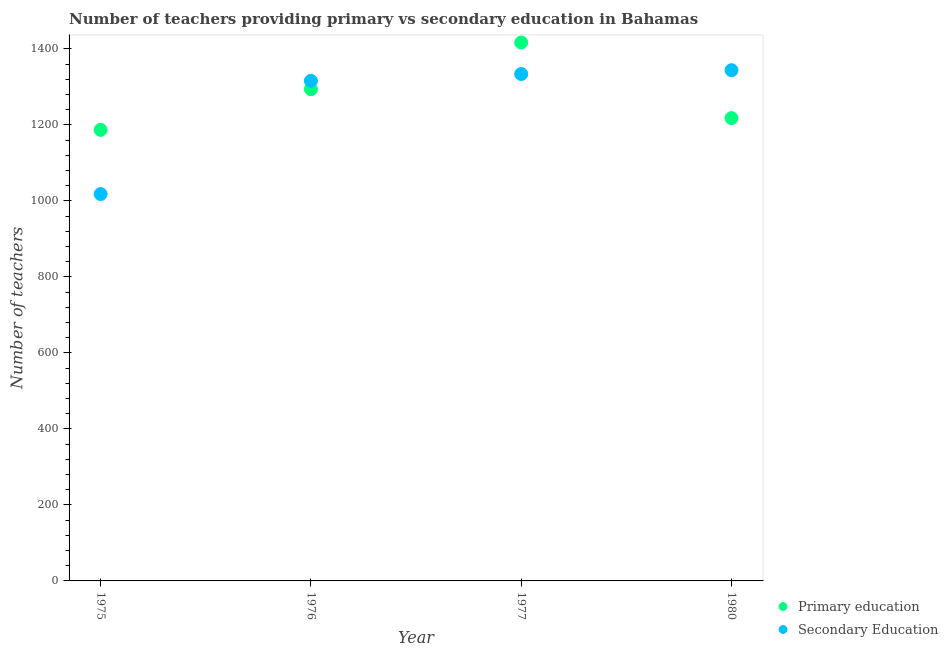Is the number of dotlines equal to the number of legend labels?
Your response must be concise. Yes. What is the number of secondary teachers in 1976?
Provide a succinct answer. 1316. Across all years, what is the maximum number of primary teachers?
Your answer should be compact. 1417. Across all years, what is the minimum number of primary teachers?
Offer a terse response. 1187. In which year was the number of secondary teachers minimum?
Your answer should be very brief. 1975. What is the total number of primary teachers in the graph?
Offer a very short reply. 5116. What is the difference between the number of primary teachers in 1976 and that in 1980?
Give a very brief answer. 76. What is the difference between the number of primary teachers in 1976 and the number of secondary teachers in 1980?
Offer a terse response. -50. What is the average number of primary teachers per year?
Ensure brevity in your answer.  1279. In the year 1975, what is the difference between the number of primary teachers and number of secondary teachers?
Offer a very short reply. 169. In how many years, is the number of primary teachers greater than 960?
Keep it short and to the point. 4. What is the ratio of the number of secondary teachers in 1976 to that in 1977?
Provide a short and direct response. 0.99. Is the number of secondary teachers in 1977 less than that in 1980?
Make the answer very short. Yes. What is the difference between the highest and the second highest number of primary teachers?
Offer a very short reply. 123. What is the difference between the highest and the lowest number of secondary teachers?
Provide a succinct answer. 326. In how many years, is the number of secondary teachers greater than the average number of secondary teachers taken over all years?
Your answer should be very brief. 3. Does the number of secondary teachers monotonically increase over the years?
Ensure brevity in your answer.  Yes. Is the number of secondary teachers strictly greater than the number of primary teachers over the years?
Your answer should be very brief. No. Is the number of secondary teachers strictly less than the number of primary teachers over the years?
Your answer should be very brief. No. How many years are there in the graph?
Your answer should be very brief. 4. What is the difference between two consecutive major ticks on the Y-axis?
Your answer should be compact. 200. Are the values on the major ticks of Y-axis written in scientific E-notation?
Keep it short and to the point. No. Does the graph contain grids?
Keep it short and to the point. No. Where does the legend appear in the graph?
Your response must be concise. Bottom right. How many legend labels are there?
Provide a short and direct response. 2. How are the legend labels stacked?
Give a very brief answer. Vertical. What is the title of the graph?
Give a very brief answer. Number of teachers providing primary vs secondary education in Bahamas. Does "Services" appear as one of the legend labels in the graph?
Your response must be concise. No. What is the label or title of the X-axis?
Your answer should be compact. Year. What is the label or title of the Y-axis?
Offer a terse response. Number of teachers. What is the Number of teachers in Primary education in 1975?
Give a very brief answer. 1187. What is the Number of teachers of Secondary Education in 1975?
Ensure brevity in your answer.  1018. What is the Number of teachers in Primary education in 1976?
Offer a very short reply. 1294. What is the Number of teachers of Secondary Education in 1976?
Your response must be concise. 1316. What is the Number of teachers of Primary education in 1977?
Offer a very short reply. 1417. What is the Number of teachers of Secondary Education in 1977?
Your answer should be compact. 1334. What is the Number of teachers of Primary education in 1980?
Offer a very short reply. 1218. What is the Number of teachers of Secondary Education in 1980?
Your response must be concise. 1344. Across all years, what is the maximum Number of teachers of Primary education?
Make the answer very short. 1417. Across all years, what is the maximum Number of teachers of Secondary Education?
Provide a succinct answer. 1344. Across all years, what is the minimum Number of teachers in Primary education?
Keep it short and to the point. 1187. Across all years, what is the minimum Number of teachers in Secondary Education?
Keep it short and to the point. 1018. What is the total Number of teachers of Primary education in the graph?
Provide a succinct answer. 5116. What is the total Number of teachers in Secondary Education in the graph?
Give a very brief answer. 5012. What is the difference between the Number of teachers in Primary education in 1975 and that in 1976?
Keep it short and to the point. -107. What is the difference between the Number of teachers in Secondary Education in 1975 and that in 1976?
Your response must be concise. -298. What is the difference between the Number of teachers of Primary education in 1975 and that in 1977?
Ensure brevity in your answer.  -230. What is the difference between the Number of teachers of Secondary Education in 1975 and that in 1977?
Your response must be concise. -316. What is the difference between the Number of teachers of Primary education in 1975 and that in 1980?
Your response must be concise. -31. What is the difference between the Number of teachers of Secondary Education in 1975 and that in 1980?
Your answer should be very brief. -326. What is the difference between the Number of teachers in Primary education in 1976 and that in 1977?
Provide a succinct answer. -123. What is the difference between the Number of teachers of Primary education in 1976 and that in 1980?
Give a very brief answer. 76. What is the difference between the Number of teachers of Primary education in 1977 and that in 1980?
Provide a succinct answer. 199. What is the difference between the Number of teachers in Primary education in 1975 and the Number of teachers in Secondary Education in 1976?
Give a very brief answer. -129. What is the difference between the Number of teachers in Primary education in 1975 and the Number of teachers in Secondary Education in 1977?
Your response must be concise. -147. What is the difference between the Number of teachers of Primary education in 1975 and the Number of teachers of Secondary Education in 1980?
Ensure brevity in your answer.  -157. What is the average Number of teachers in Primary education per year?
Your response must be concise. 1279. What is the average Number of teachers in Secondary Education per year?
Ensure brevity in your answer.  1253. In the year 1975, what is the difference between the Number of teachers of Primary education and Number of teachers of Secondary Education?
Ensure brevity in your answer.  169. In the year 1976, what is the difference between the Number of teachers in Primary education and Number of teachers in Secondary Education?
Keep it short and to the point. -22. In the year 1977, what is the difference between the Number of teachers in Primary education and Number of teachers in Secondary Education?
Make the answer very short. 83. In the year 1980, what is the difference between the Number of teachers in Primary education and Number of teachers in Secondary Education?
Your response must be concise. -126. What is the ratio of the Number of teachers in Primary education in 1975 to that in 1976?
Your response must be concise. 0.92. What is the ratio of the Number of teachers of Secondary Education in 1975 to that in 1976?
Keep it short and to the point. 0.77. What is the ratio of the Number of teachers in Primary education in 1975 to that in 1977?
Provide a short and direct response. 0.84. What is the ratio of the Number of teachers of Secondary Education in 1975 to that in 1977?
Provide a short and direct response. 0.76. What is the ratio of the Number of teachers of Primary education in 1975 to that in 1980?
Your answer should be very brief. 0.97. What is the ratio of the Number of teachers in Secondary Education in 1975 to that in 1980?
Make the answer very short. 0.76. What is the ratio of the Number of teachers of Primary education in 1976 to that in 1977?
Offer a terse response. 0.91. What is the ratio of the Number of teachers in Secondary Education in 1976 to that in 1977?
Offer a terse response. 0.99. What is the ratio of the Number of teachers of Primary education in 1976 to that in 1980?
Your response must be concise. 1.06. What is the ratio of the Number of teachers of Secondary Education in 1976 to that in 1980?
Your response must be concise. 0.98. What is the ratio of the Number of teachers of Primary education in 1977 to that in 1980?
Your answer should be compact. 1.16. What is the ratio of the Number of teachers of Secondary Education in 1977 to that in 1980?
Provide a succinct answer. 0.99. What is the difference between the highest and the second highest Number of teachers in Primary education?
Ensure brevity in your answer.  123. What is the difference between the highest and the second highest Number of teachers of Secondary Education?
Make the answer very short. 10. What is the difference between the highest and the lowest Number of teachers in Primary education?
Keep it short and to the point. 230. What is the difference between the highest and the lowest Number of teachers of Secondary Education?
Provide a succinct answer. 326. 